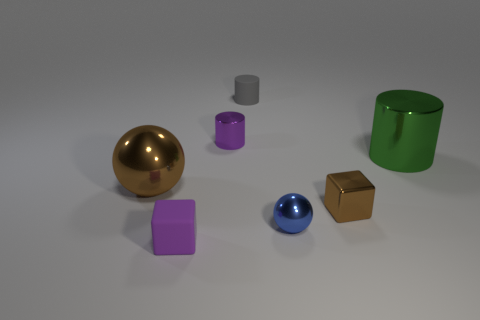Subtract all metallic cylinders. How many cylinders are left? 1 Add 1 yellow blocks. How many objects exist? 8 Subtract all spheres. How many objects are left? 5 Subtract all small blue shiny objects. Subtract all cubes. How many objects are left? 4 Add 3 tiny purple things. How many tiny purple things are left? 5 Add 4 big yellow objects. How many big yellow objects exist? 4 Subtract 1 purple cylinders. How many objects are left? 6 